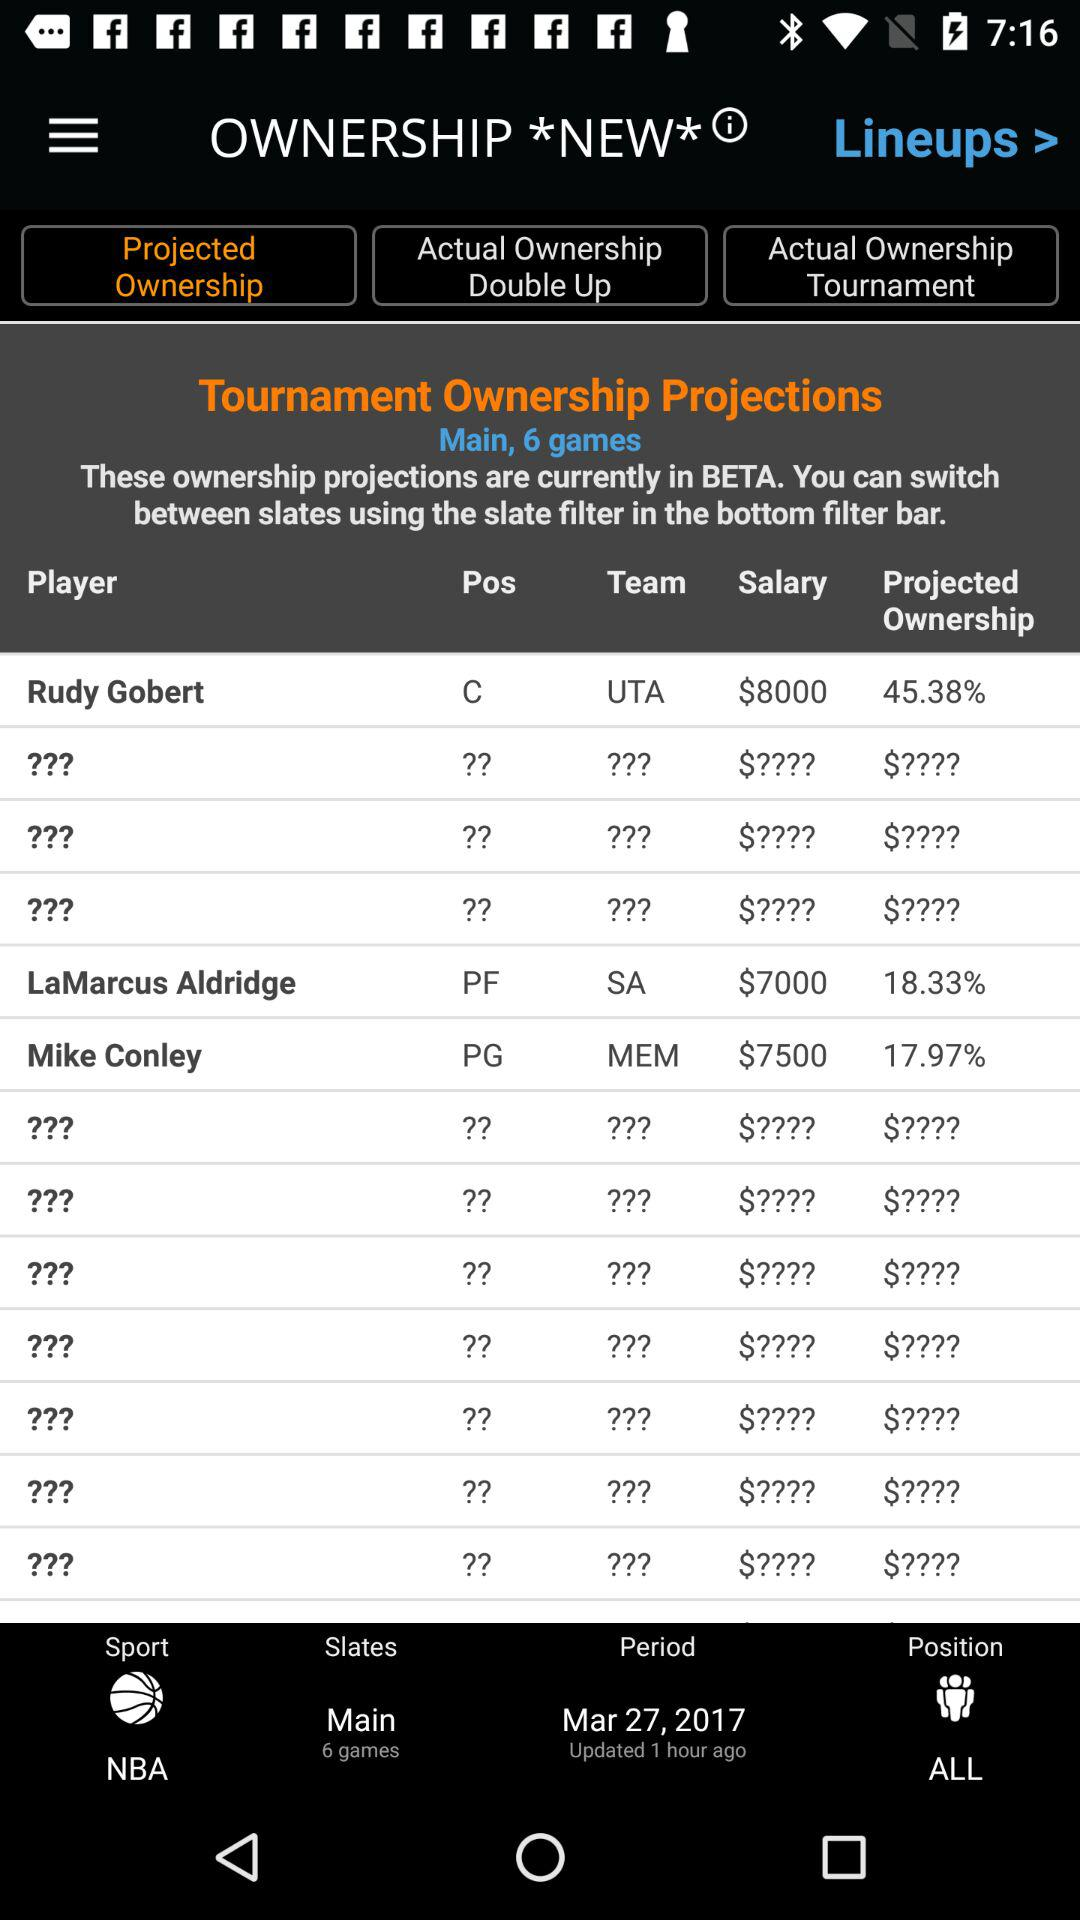What is the salary of Rudy Gobert? The salary is $8000. 